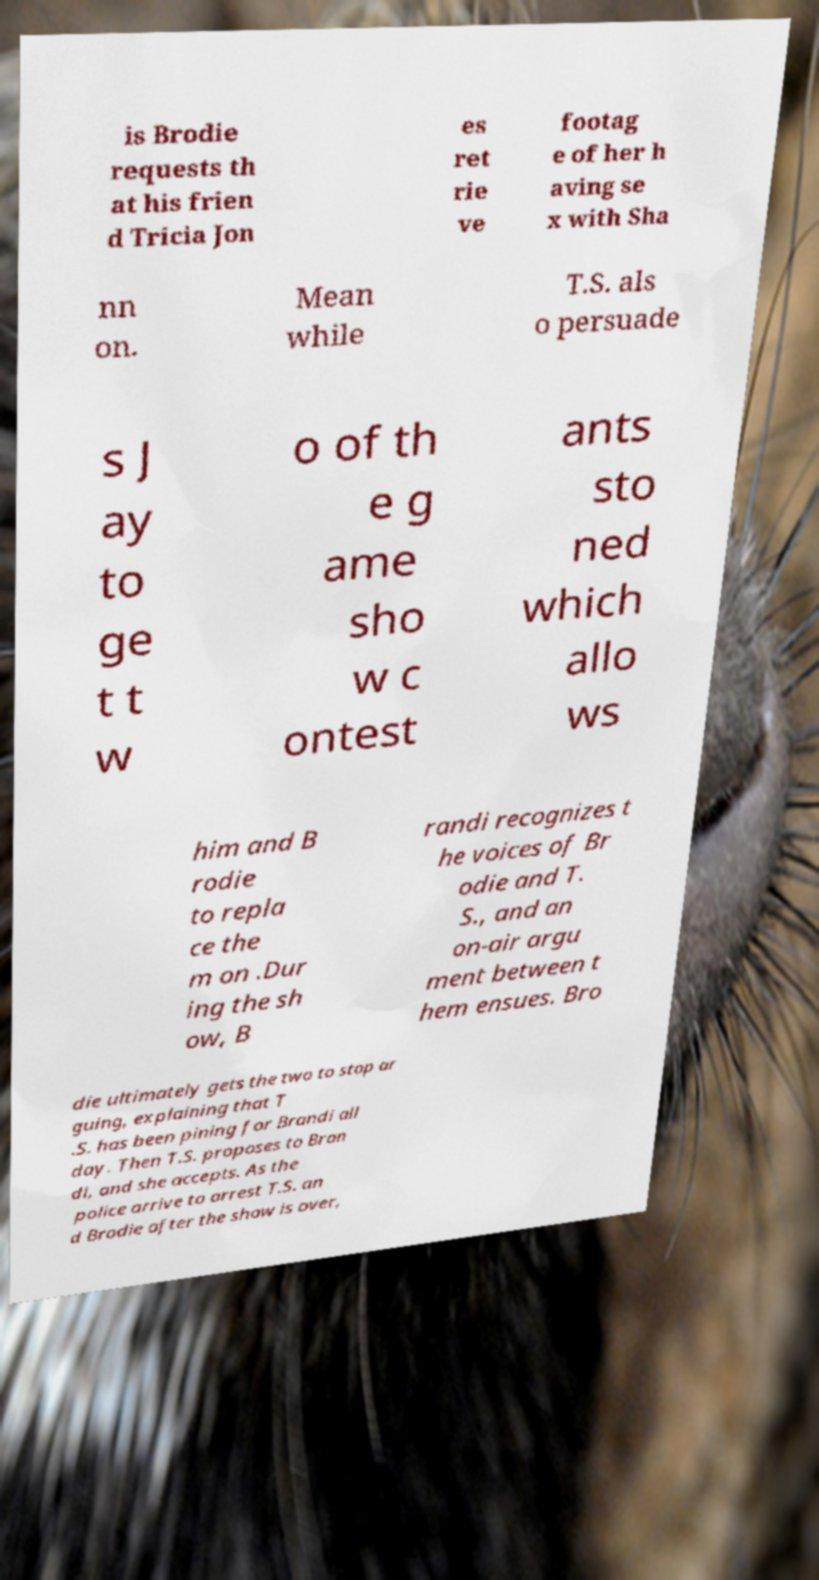Please identify and transcribe the text found in this image. is Brodie requests th at his frien d Tricia Jon es ret rie ve footag e of her h aving se x with Sha nn on. Mean while T.S. als o persuade s J ay to ge t t w o of th e g ame sho w c ontest ants sto ned which allo ws him and B rodie to repla ce the m on .Dur ing the sh ow, B randi recognizes t he voices of Br odie and T. S., and an on-air argu ment between t hem ensues. Bro die ultimately gets the two to stop ar guing, explaining that T .S. has been pining for Brandi all day. Then T.S. proposes to Bran di, and she accepts. As the police arrive to arrest T.S. an d Brodie after the show is over, 